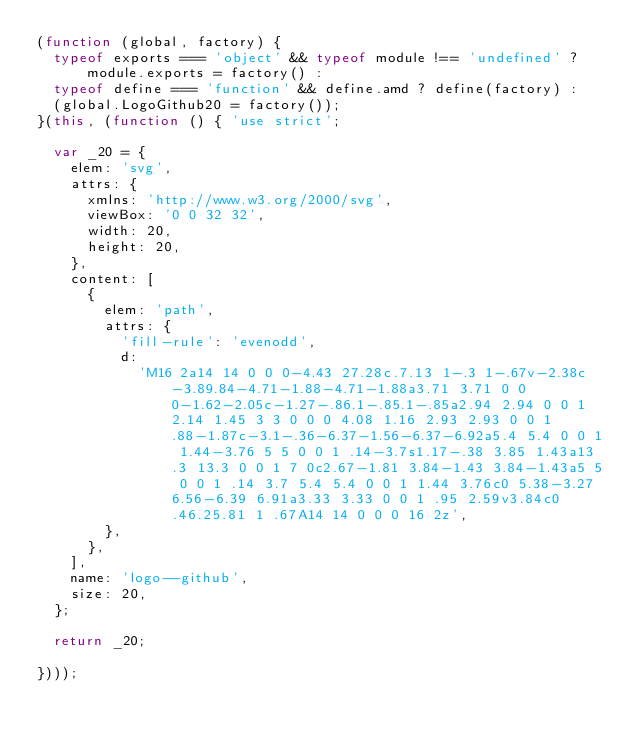<code> <loc_0><loc_0><loc_500><loc_500><_JavaScript_>(function (global, factory) {
  typeof exports === 'object' && typeof module !== 'undefined' ? module.exports = factory() :
  typeof define === 'function' && define.amd ? define(factory) :
  (global.LogoGithub20 = factory());
}(this, (function () { 'use strict';

  var _20 = {
    elem: 'svg',
    attrs: {
      xmlns: 'http://www.w3.org/2000/svg',
      viewBox: '0 0 32 32',
      width: 20,
      height: 20,
    },
    content: [
      {
        elem: 'path',
        attrs: {
          'fill-rule': 'evenodd',
          d:
            'M16 2a14 14 0 0 0-4.43 27.28c.7.13 1-.3 1-.67v-2.38c-3.89.84-4.71-1.88-4.71-1.88a3.71 3.71 0 0 0-1.62-2.05c-1.27-.86.1-.85.1-.85a2.94 2.94 0 0 1 2.14 1.45 3 3 0 0 0 4.08 1.16 2.93 2.93 0 0 1 .88-1.87c-3.1-.36-6.37-1.56-6.37-6.92a5.4 5.4 0 0 1 1.44-3.76 5 5 0 0 1 .14-3.7s1.17-.38 3.85 1.43a13.3 13.3 0 0 1 7 0c2.67-1.81 3.84-1.43 3.84-1.43a5 5 0 0 1 .14 3.7 5.4 5.4 0 0 1 1.44 3.76c0 5.38-3.27 6.56-6.39 6.91a3.33 3.33 0 0 1 .95 2.59v3.84c0 .46.25.81 1 .67A14 14 0 0 0 16 2z',
        },
      },
    ],
    name: 'logo--github',
    size: 20,
  };

  return _20;

})));
</code> 